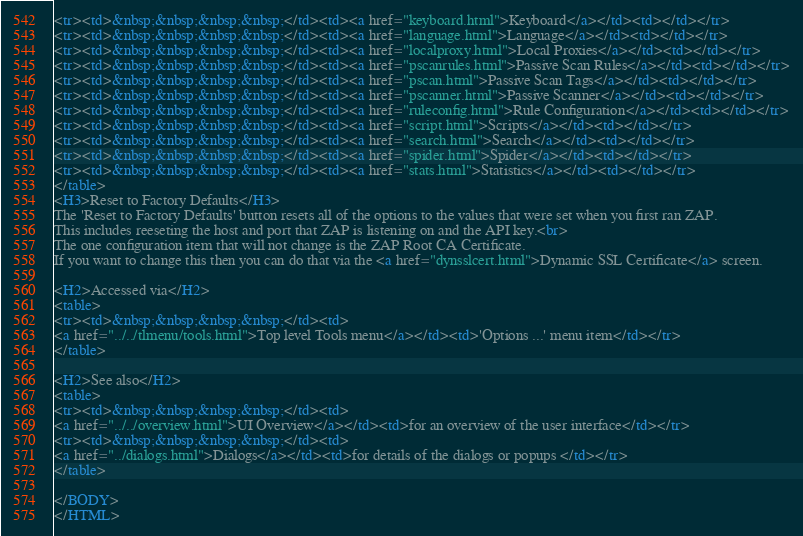<code> <loc_0><loc_0><loc_500><loc_500><_HTML_><tr><td>&nbsp;&nbsp;&nbsp;&nbsp;</td><td><a href="keyboard.html">Keyboard</a></td><td></td></tr>
<tr><td>&nbsp;&nbsp;&nbsp;&nbsp;</td><td><a href="language.html">Language</a></td><td></td></tr>
<tr><td>&nbsp;&nbsp;&nbsp;&nbsp;</td><td><a href="localproxy.html">Local Proxies</a></td><td></td></tr>
<tr><td>&nbsp;&nbsp;&nbsp;&nbsp;</td><td><a href="pscanrules.html">Passive Scan Rules</a></td><td></td></tr>
<tr><td>&nbsp;&nbsp;&nbsp;&nbsp;</td><td><a href="pscan.html">Passive Scan Tags</a></td><td></td></tr>
<tr><td>&nbsp;&nbsp;&nbsp;&nbsp;</td><td><a href="pscanner.html">Passive Scanner</a></td><td></td></tr>
<tr><td>&nbsp;&nbsp;&nbsp;&nbsp;</td><td><a href="ruleconfig.html">Rule Configuration</a></td><td></td></tr>
<tr><td>&nbsp;&nbsp;&nbsp;&nbsp;</td><td><a href="script.html">Scripts</a></td><td></td></tr>
<tr><td>&nbsp;&nbsp;&nbsp;&nbsp;</td><td><a href="search.html">Search</a></td><td></td></tr>
<tr><td>&nbsp;&nbsp;&nbsp;&nbsp;</td><td><a href="spider.html">Spider</a></td><td></td></tr>
<tr><td>&nbsp;&nbsp;&nbsp;&nbsp;</td><td><a href="stats.html">Statistics</a></td><td></td></tr>
</table>
<H3>Reset to Factory Defaults</H3>
The 'Reset to Factory Defaults' button resets all of the options to the values that were set when you first ran ZAP.
This includes reeseting the host and port that ZAP is listening on and the API key.<br>
The one configuration item that will not change is the ZAP Root CA Certificate.
If you want to change this then you can do that via the <a href="dynsslcert.html">Dynamic SSL Certificate</a> screen.

<H2>Accessed via</H2>
<table>
<tr><td>&nbsp;&nbsp;&nbsp;&nbsp;</td><td>
<a href="../../tlmenu/tools.html">Top level Tools menu</a></td><td>'Options ...' menu item</td></tr>
</table>

<H2>See also</H2>
<table>
<tr><td>&nbsp;&nbsp;&nbsp;&nbsp;</td><td>
<a href="../../overview.html">UI Overview</a></td><td>for an overview of the user interface</td></tr>
<tr><td>&nbsp;&nbsp;&nbsp;&nbsp;</td><td>
<a href="../dialogs.html">Dialogs</a></td><td>for details of the dialogs or popups </td></tr>
</table>

</BODY>
</HTML>
</code> 